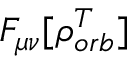<formula> <loc_0><loc_0><loc_500><loc_500>F _ { \mu \nu } [ \rho _ { o r b } ^ { T } ]</formula> 